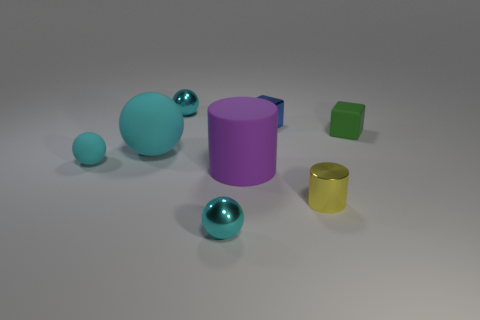There is a big rubber thing to the left of the cyan metal sphere in front of the tiny cylinder; what is its color?
Provide a succinct answer. Cyan. What number of rubber balls are in front of the purple cylinder?
Your response must be concise. 0. What is the color of the big cylinder?
Give a very brief answer. Purple. What number of big things are purple rubber cylinders or rubber objects?
Provide a short and direct response. 2. Do the thing in front of the small yellow cylinder and the cylinder on the left side of the yellow thing have the same color?
Give a very brief answer. No. What number of other objects are the same color as the big ball?
Your answer should be very brief. 3. There is a cyan object that is in front of the small cyan rubber ball; what is its shape?
Provide a succinct answer. Sphere. Is the number of small green rubber cubes less than the number of big blue rubber cubes?
Your answer should be compact. No. Do the small thing that is behind the tiny metallic cube and the small blue object have the same material?
Provide a short and direct response. Yes. Are there any other things that are the same size as the matte cylinder?
Keep it short and to the point. Yes. 